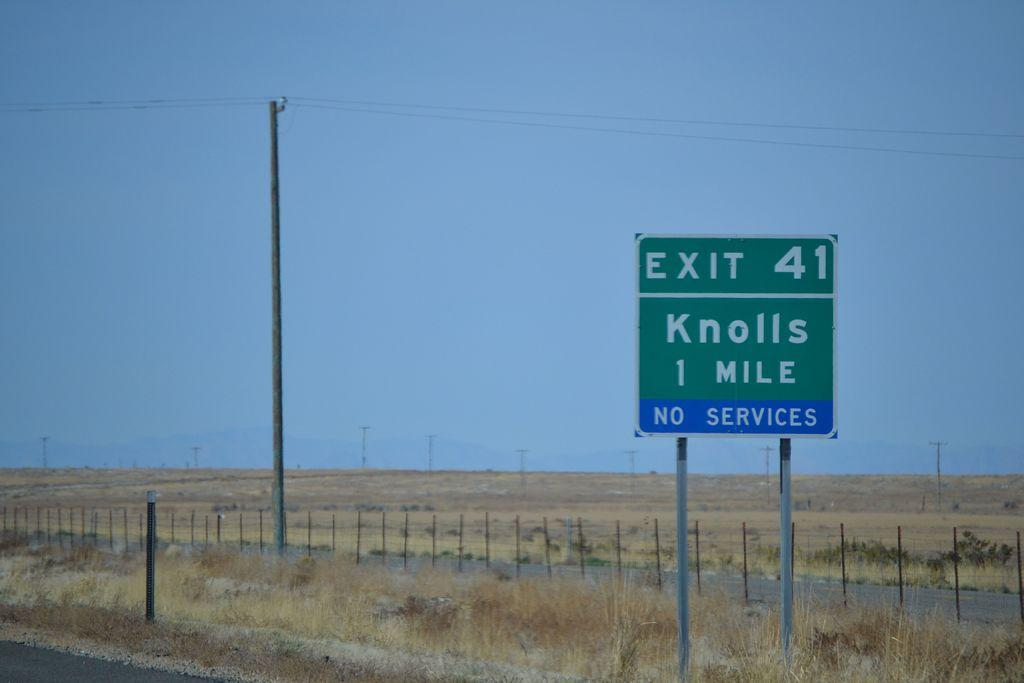<image>
Summarize the visual content of the image. A sign on the side of the road indicates that there are no services in Knolls. 